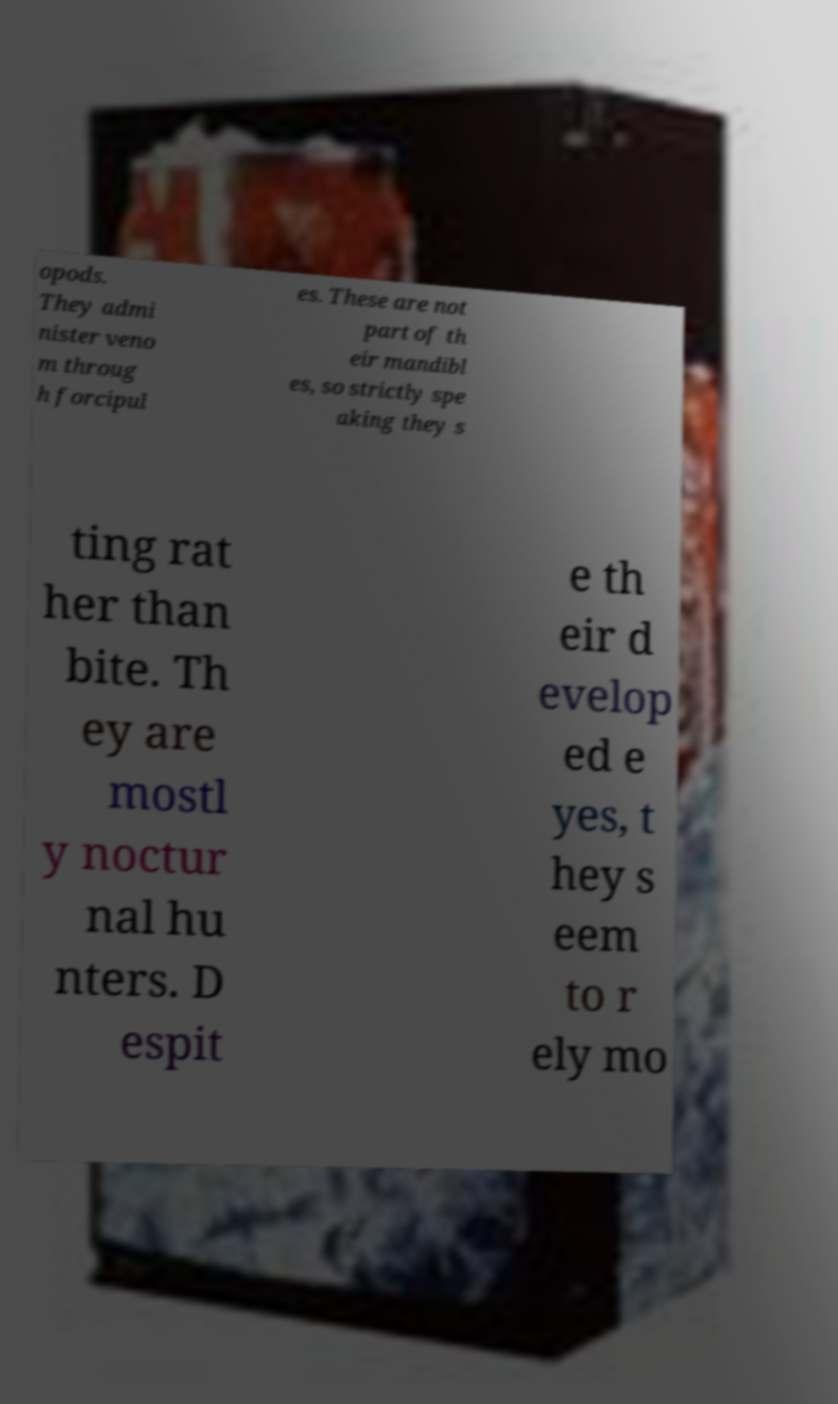For documentation purposes, I need the text within this image transcribed. Could you provide that? opods. They admi nister veno m throug h forcipul es. These are not part of th eir mandibl es, so strictly spe aking they s ting rat her than bite. Th ey are mostl y noctur nal hu nters. D espit e th eir d evelop ed e yes, t hey s eem to r ely mo 